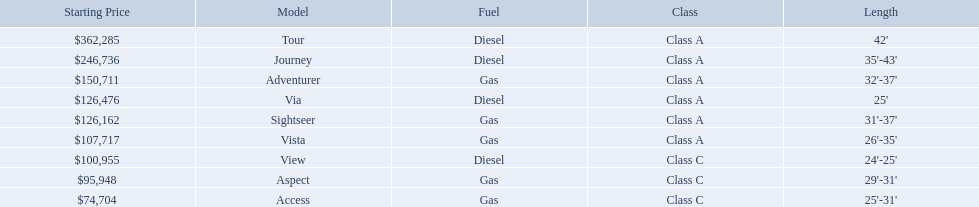What are all of the winnebago models? Tour, Journey, Adventurer, Via, Sightseer, Vista, View, Aspect, Access. What are their prices? $362,285, $246,736, $150,711, $126,476, $126,162, $107,717, $100,955, $95,948, $74,704. And which model costs the most? Tour. Which model has the lowest starting price? Access. Which model has the second most highest starting price? Journey. Which model has the highest price in the winnebago industry? Tour. 